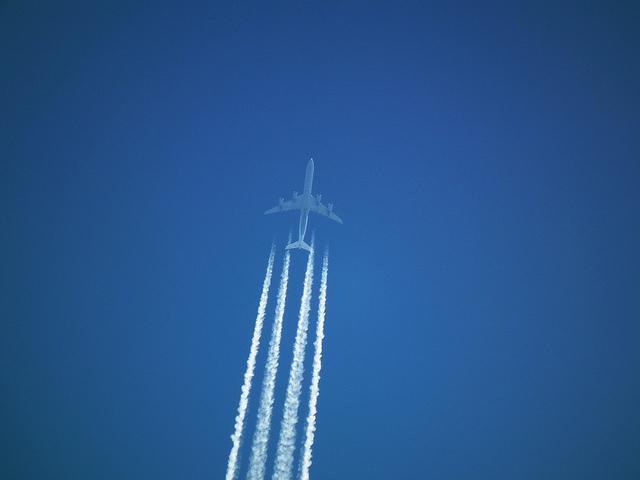How many lines of smoke are trailing the plane?
Give a very brief answer. 4. How many engines does the plane have?
Give a very brief answer. 4. 